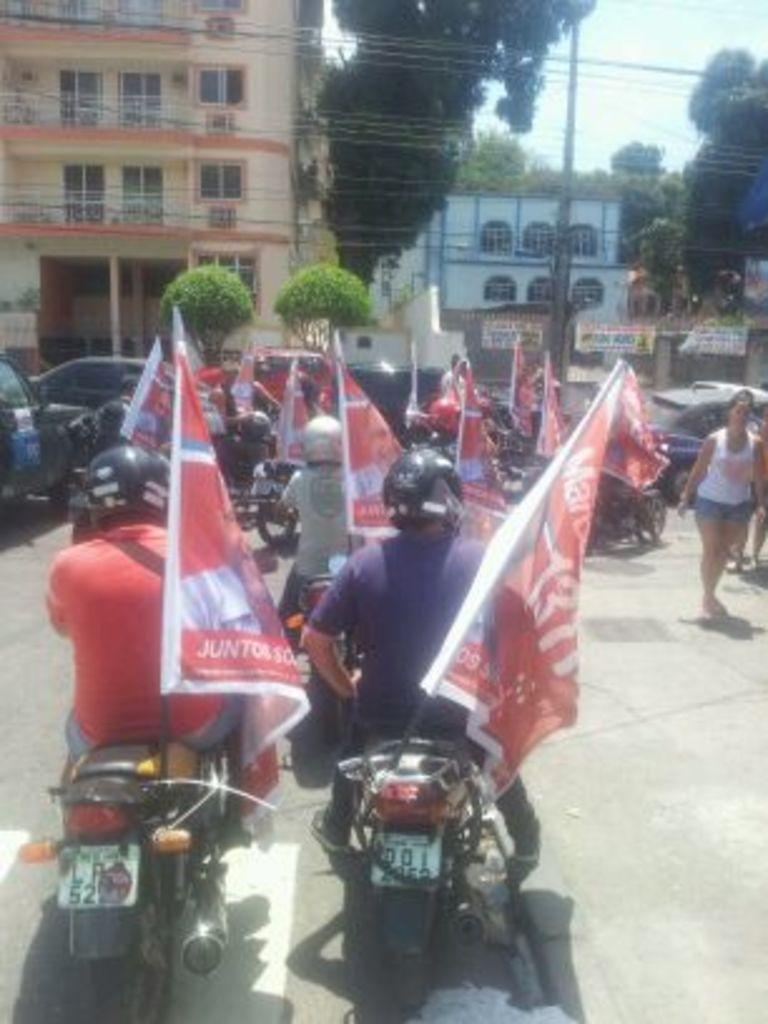How many persons are in the image? There is a group of persons in the image. What are the persons doing in the image? The persons are riding bikes. What object are they holding while riding bikes? They are holding a flag. What can be seen in the background of the image? There is a building, a car, trees, buildings, banners, and the sky visible in the background of the image. What is the condition of the sky in the image? The sky is covered with clouds. What type of glue is being used to attach the banners to the buildings in the image? There is no indication in the image that glue is being used to attach the banners to the buildings. Can you describe the maid in the image? There is no maid present in the image. 